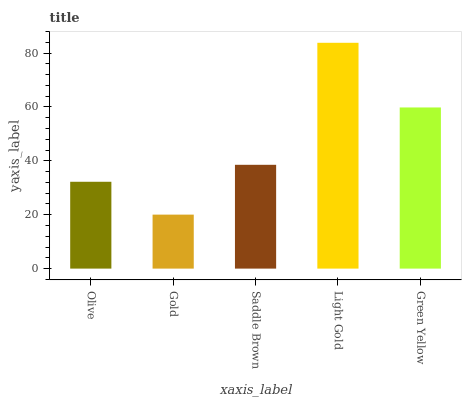Is Gold the minimum?
Answer yes or no. Yes. Is Light Gold the maximum?
Answer yes or no. Yes. Is Saddle Brown the minimum?
Answer yes or no. No. Is Saddle Brown the maximum?
Answer yes or no. No. Is Saddle Brown greater than Gold?
Answer yes or no. Yes. Is Gold less than Saddle Brown?
Answer yes or no. Yes. Is Gold greater than Saddle Brown?
Answer yes or no. No. Is Saddle Brown less than Gold?
Answer yes or no. No. Is Saddle Brown the high median?
Answer yes or no. Yes. Is Saddle Brown the low median?
Answer yes or no. Yes. Is Olive the high median?
Answer yes or no. No. Is Light Gold the low median?
Answer yes or no. No. 